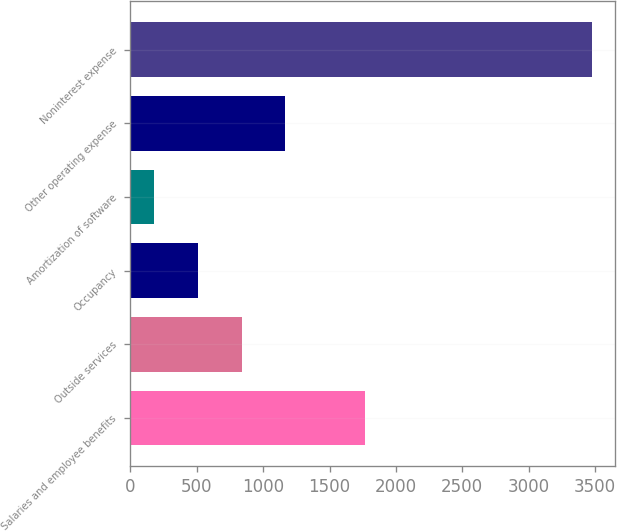Convert chart. <chart><loc_0><loc_0><loc_500><loc_500><bar_chart><fcel>Salaries and employee benefits<fcel>Outside services<fcel>Occupancy<fcel>Amortization of software<fcel>Other operating expense<fcel>Noninterest expense<nl><fcel>1766<fcel>838.8<fcel>509.4<fcel>180<fcel>1168.2<fcel>3474<nl></chart> 